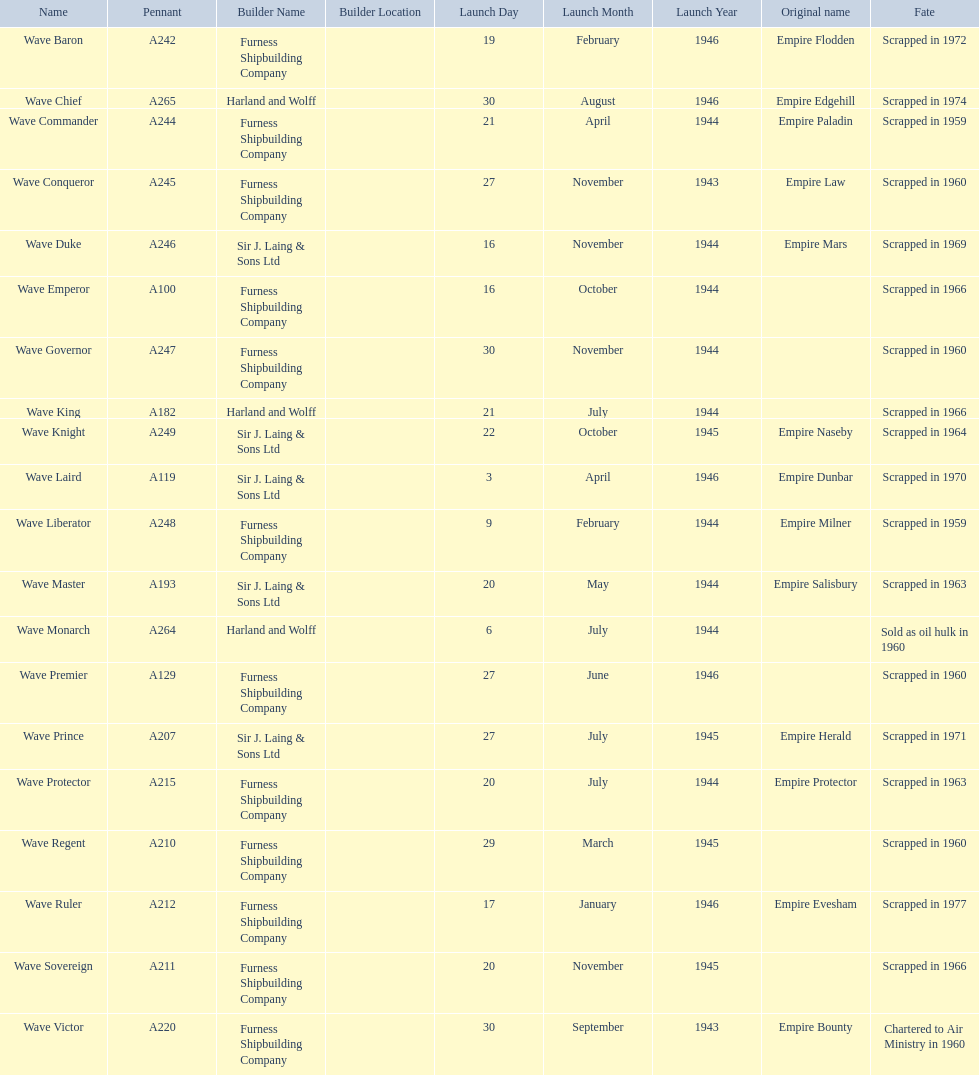What year was the wave victor launched? 30 September 1943. What other ship was launched in 1943? Wave Conqueror. 